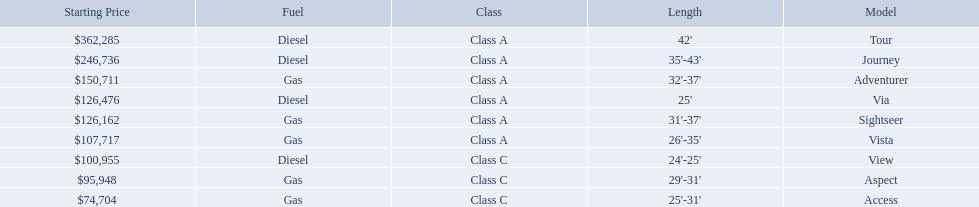Which model has the lowest starting price? Access. Which model has the second most highest starting price? Journey. Which model has the highest price in the winnebago industry? Tour. 